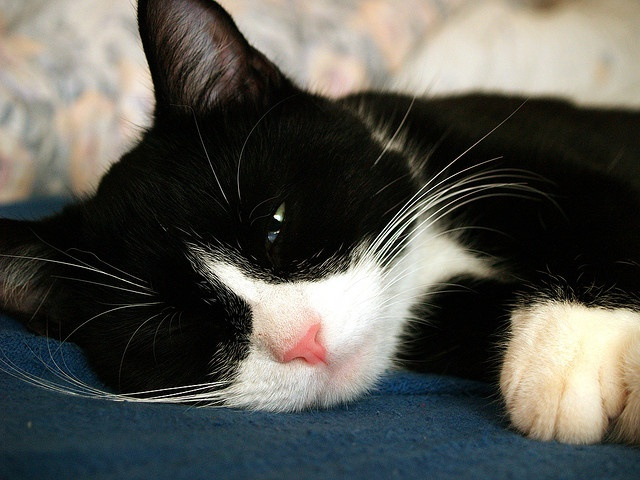Describe the objects in this image and their specific colors. I can see cat in black, darkgray, ivory, gray, and tan tones and bed in darkgray, darkblue, navy, and lightgray tones in this image. 